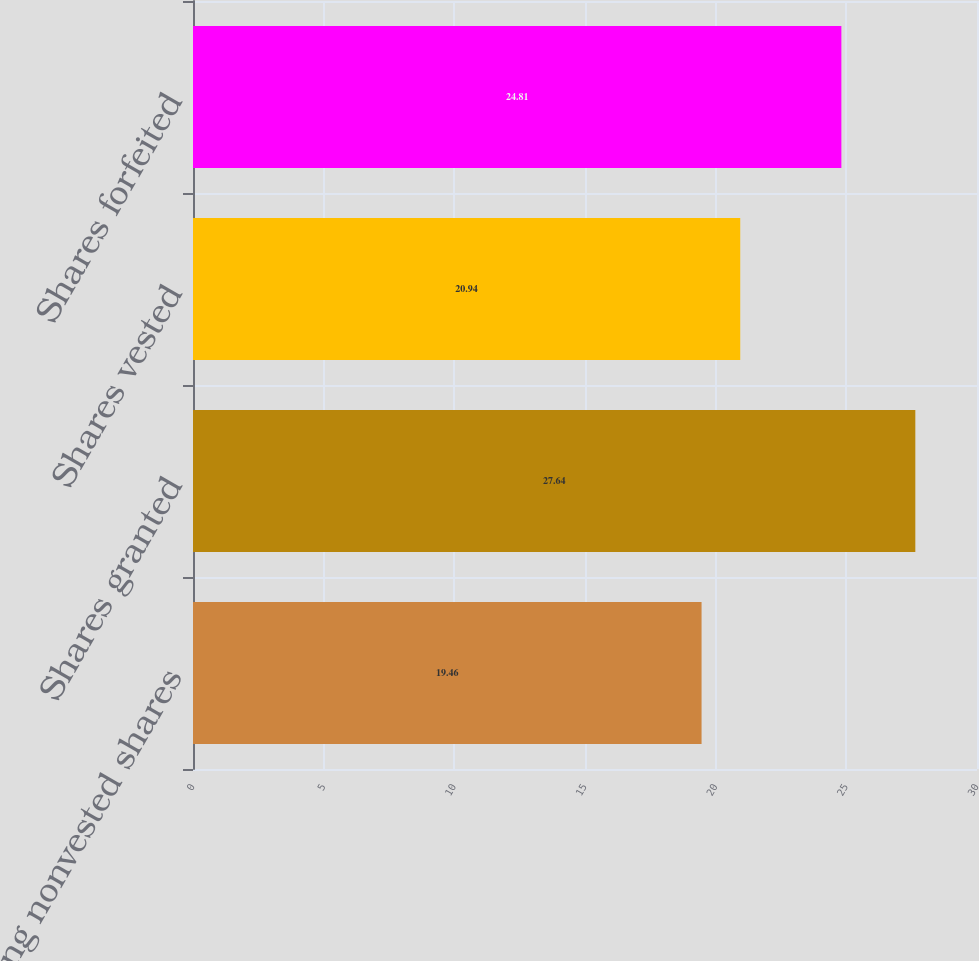Convert chart. <chart><loc_0><loc_0><loc_500><loc_500><bar_chart><fcel>Outstanding nonvested shares<fcel>Shares granted<fcel>Shares vested<fcel>Shares forfeited<nl><fcel>19.46<fcel>27.64<fcel>20.94<fcel>24.81<nl></chart> 